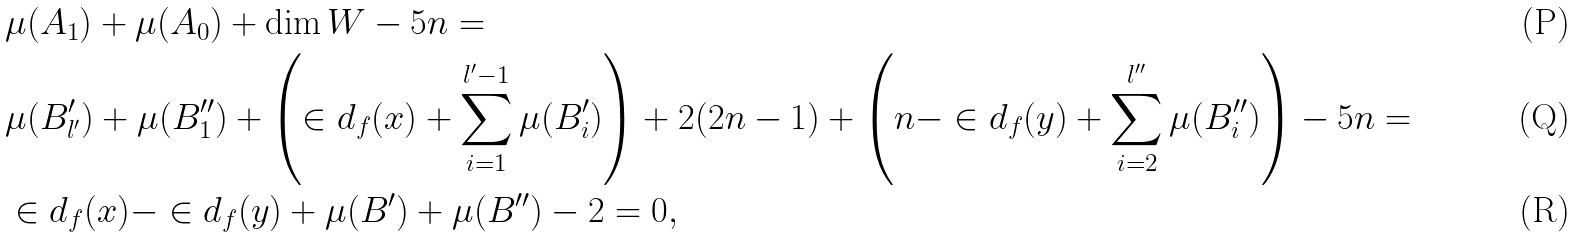Convert formula to latex. <formula><loc_0><loc_0><loc_500><loc_500>& \mu ( A _ { 1 } ) + \mu ( A _ { 0 } ) + \dim W - 5 n = \\ & \mu ( B ^ { \prime } _ { l ^ { \prime } } ) + \mu ( B ^ { \prime \prime } _ { 1 } ) + \left ( \in d _ { f } ( x ) + \sum _ { i = 1 } ^ { l ^ { \prime } - 1 } \mu ( B ^ { \prime } _ { i } ) \right ) + 2 ( 2 n - 1 ) + \left ( n - \in d _ { f } ( y ) + \sum _ { i = 2 } ^ { l ^ { \prime \prime } } \mu ( B ^ { \prime \prime } _ { i } ) \right ) - 5 n = \\ & \in d _ { f } ( x ) - \in d _ { f } ( y ) + \mu ( B ^ { \prime } ) + \mu ( B ^ { \prime \prime } ) - 2 = 0 ,</formula> 